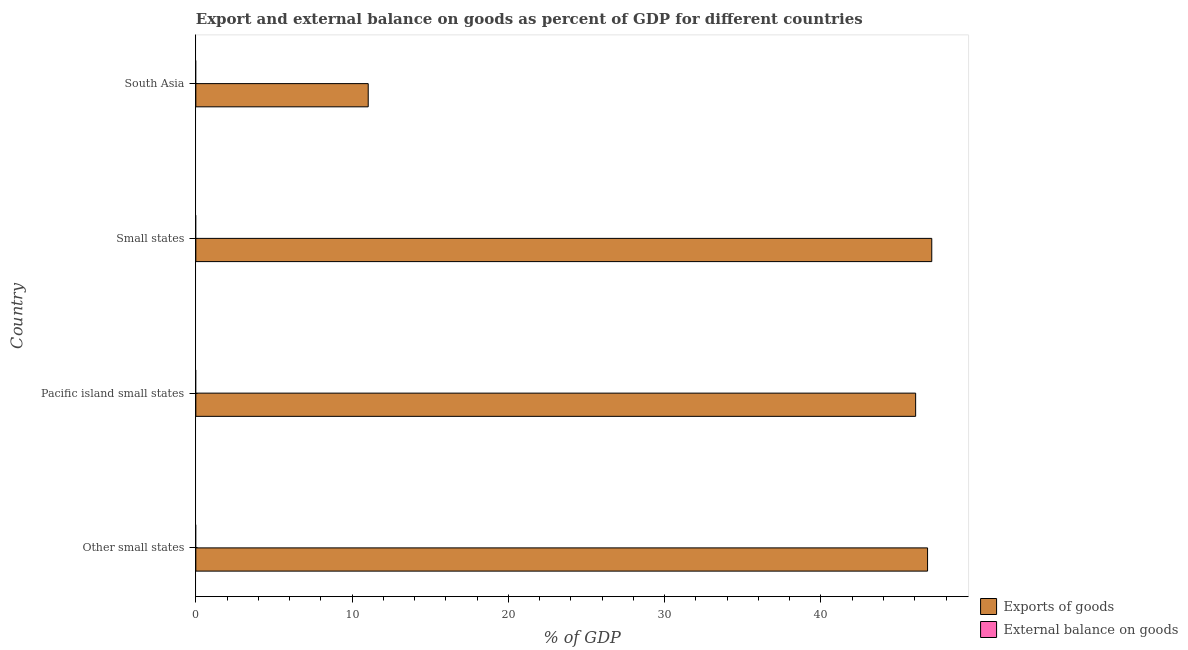Are the number of bars per tick equal to the number of legend labels?
Your response must be concise. No. Are the number of bars on each tick of the Y-axis equal?
Make the answer very short. Yes. How many bars are there on the 3rd tick from the top?
Provide a short and direct response. 1. What is the label of the 4th group of bars from the top?
Give a very brief answer. Other small states. In how many cases, is the number of bars for a given country not equal to the number of legend labels?
Provide a succinct answer. 4. What is the export of goods as percentage of gdp in South Asia?
Provide a succinct answer. 11.03. Across all countries, what is the maximum export of goods as percentage of gdp?
Provide a succinct answer. 47.09. Across all countries, what is the minimum external balance on goods as percentage of gdp?
Offer a terse response. 0. In which country was the export of goods as percentage of gdp maximum?
Offer a very short reply. Small states. What is the total export of goods as percentage of gdp in the graph?
Your answer should be very brief. 151. What is the difference between the export of goods as percentage of gdp in Pacific island small states and that in Small states?
Ensure brevity in your answer.  -1.03. What is the difference between the export of goods as percentage of gdp in Pacific island small states and the external balance on goods as percentage of gdp in South Asia?
Offer a terse response. 46.06. What is the average export of goods as percentage of gdp per country?
Your response must be concise. 37.75. What is the ratio of the export of goods as percentage of gdp in Other small states to that in South Asia?
Your answer should be compact. 4.25. Is the export of goods as percentage of gdp in Other small states less than that in South Asia?
Keep it short and to the point. No. What is the difference between the highest and the second highest export of goods as percentage of gdp?
Your answer should be very brief. 0.27. What is the difference between the highest and the lowest export of goods as percentage of gdp?
Offer a very short reply. 36.06. Are the values on the major ticks of X-axis written in scientific E-notation?
Your answer should be compact. No. Does the graph contain any zero values?
Give a very brief answer. Yes. Where does the legend appear in the graph?
Your answer should be very brief. Bottom right. How are the legend labels stacked?
Provide a short and direct response. Vertical. What is the title of the graph?
Give a very brief answer. Export and external balance on goods as percent of GDP for different countries. What is the label or title of the X-axis?
Keep it short and to the point. % of GDP. What is the % of GDP of Exports of goods in Other small states?
Your response must be concise. 46.82. What is the % of GDP in Exports of goods in Pacific island small states?
Your response must be concise. 46.06. What is the % of GDP in External balance on goods in Pacific island small states?
Your answer should be very brief. 0. What is the % of GDP of Exports of goods in Small states?
Your answer should be compact. 47.09. What is the % of GDP of Exports of goods in South Asia?
Your answer should be very brief. 11.03. What is the % of GDP in External balance on goods in South Asia?
Offer a very short reply. 0. Across all countries, what is the maximum % of GDP in Exports of goods?
Make the answer very short. 47.09. Across all countries, what is the minimum % of GDP of Exports of goods?
Keep it short and to the point. 11.03. What is the total % of GDP in Exports of goods in the graph?
Make the answer very short. 151. What is the difference between the % of GDP in Exports of goods in Other small states and that in Pacific island small states?
Offer a very short reply. 0.76. What is the difference between the % of GDP in Exports of goods in Other small states and that in Small states?
Provide a short and direct response. -0.27. What is the difference between the % of GDP of Exports of goods in Other small states and that in South Asia?
Your response must be concise. 35.79. What is the difference between the % of GDP of Exports of goods in Pacific island small states and that in Small states?
Ensure brevity in your answer.  -1.03. What is the difference between the % of GDP of Exports of goods in Pacific island small states and that in South Asia?
Provide a succinct answer. 35.03. What is the difference between the % of GDP of Exports of goods in Small states and that in South Asia?
Make the answer very short. 36.06. What is the average % of GDP of Exports of goods per country?
Provide a succinct answer. 37.75. What is the average % of GDP in External balance on goods per country?
Keep it short and to the point. 0. What is the ratio of the % of GDP of Exports of goods in Other small states to that in Pacific island small states?
Ensure brevity in your answer.  1.02. What is the ratio of the % of GDP of Exports of goods in Other small states to that in South Asia?
Your response must be concise. 4.24. What is the ratio of the % of GDP in Exports of goods in Pacific island small states to that in Small states?
Provide a short and direct response. 0.98. What is the ratio of the % of GDP in Exports of goods in Pacific island small states to that in South Asia?
Your answer should be very brief. 4.18. What is the ratio of the % of GDP of Exports of goods in Small states to that in South Asia?
Offer a terse response. 4.27. What is the difference between the highest and the second highest % of GDP in Exports of goods?
Your response must be concise. 0.27. What is the difference between the highest and the lowest % of GDP in Exports of goods?
Provide a succinct answer. 36.06. 